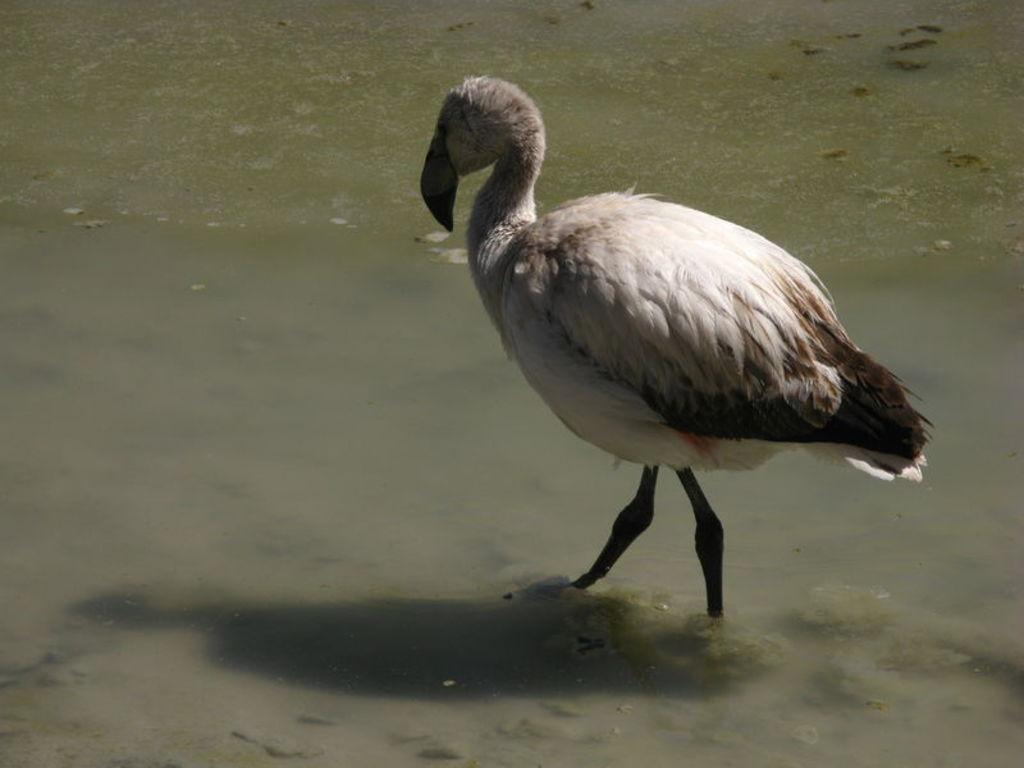What animal is present in the image? There is a duck in the image. What is the duck doing in the image? The duck is walking in the water. What type of skirt is the duck wearing in the image? There is no skirt present in the image, as ducks do not wear clothing. 